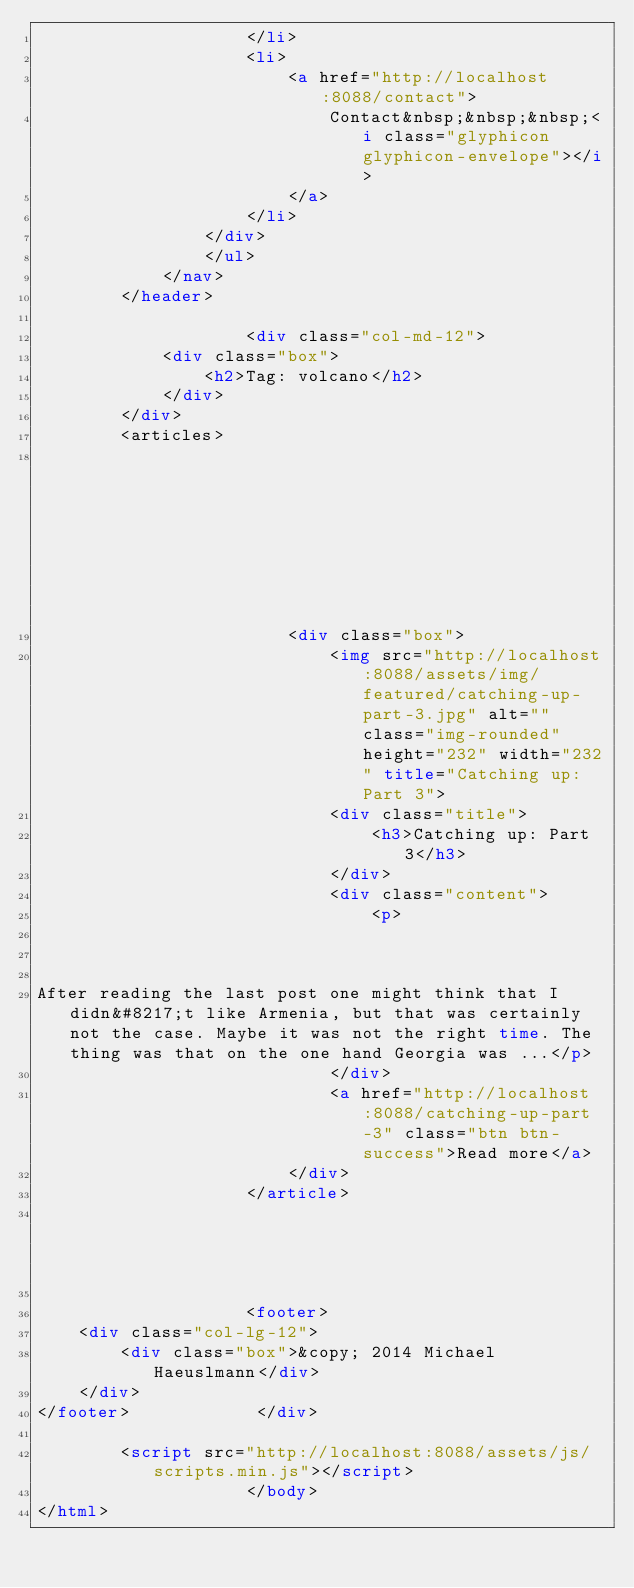<code> <loc_0><loc_0><loc_500><loc_500><_HTML_>                    </li>
                    <li>
                        <a href="http://localhost:8088/contact">
                            Contact&nbsp;&nbsp;&nbsp;<i class="glyphicon glyphicon-envelope"></i>
                        </a>
                    </li>
                </div>
                </ul>
            </nav>
        </header>

                    <div class="col-md-12">
            <div class="box">
                <h2>Tag: volcano</h2>
            </div>
        </div>
        <articles>
                                                                                                                                                                                                                                                                                                                                                                                                                                                                                                                                                                                                                    <article class="">
                        <div class="box">
                            <img src="http://localhost:8088/assets/img/featured/catching-up-part-3.jpg" alt="" class="img-rounded" height="232" width="232" title="Catching up: Part 3">
                            <div class="title">
                                <h3>Catching up: Part 3</h3>
                            </div>
                            <div class="content">
                                <p>
  


After reading the last post one might think that I didn&#8217;t like Armenia, but that was certainly not the case. Maybe it was not the right time. The thing was that on the one hand Georgia was ...</p>
                            </div>
                            <a href="http://localhost:8088/catching-up-part-3" class="btn btn-success">Read more</a>
                        </div>
                    </article>
                                                                                                                                                                                                                                                                                                                                                                                                                                    </articles>

                    <footer>
    <div class="col-lg-12">
        <div class="box">&copy; 2014 Michael Haeuslmann</div>
    </div>
</footer>            </div>
    
        <script src="http://localhost:8088/assets/js/scripts.min.js"></script>
                    </body>
</html>
</code> 